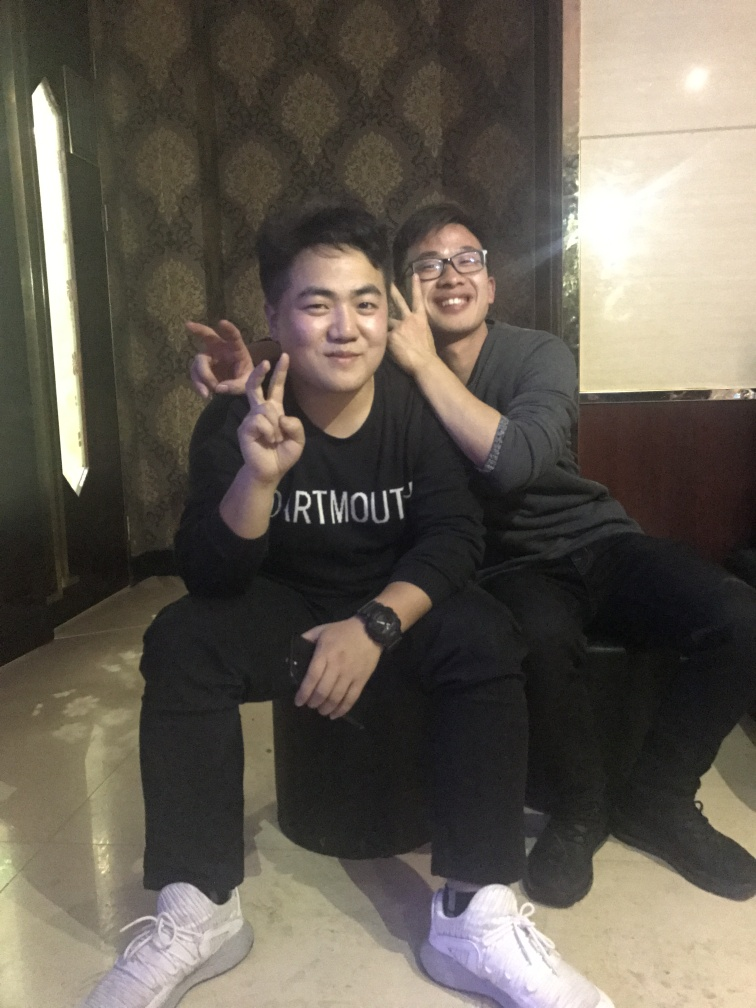Is the main subject, the person being photographed, quite clear? Yes, the main subject, who appears to be the individual in the foreground making a peace sign, is quite clear. The focus and lighting conditions highlight this individual, drawing the viewer's attention to them as the primary figure in this photograph. 